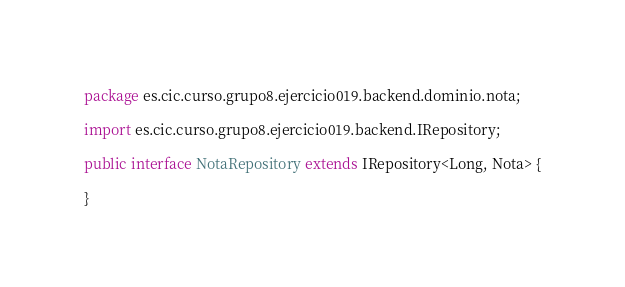<code> <loc_0><loc_0><loc_500><loc_500><_Java_>package es.cic.curso.grupo8.ejercicio019.backend.dominio.nota;

import es.cic.curso.grupo8.ejercicio019.backend.IRepository;

public interface NotaRepository extends IRepository<Long, Nota> {

}
</code> 